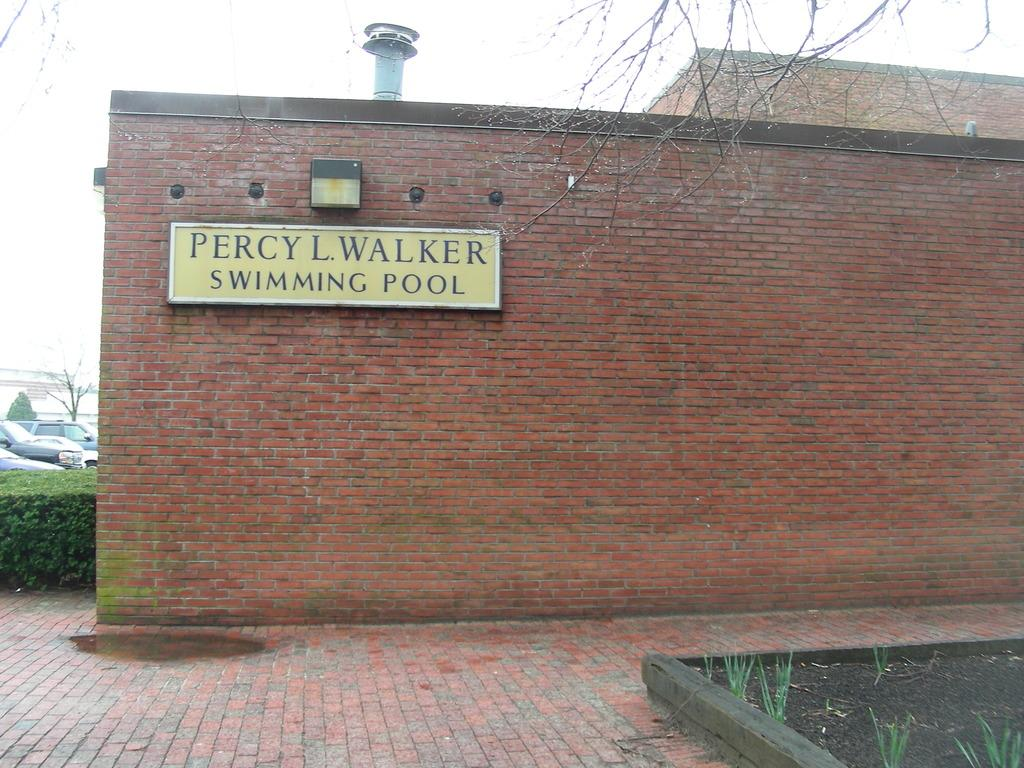What type of living organisms can be seen in the image? Plants and trees are visible in the image. What else can be seen in the image besides plants and trees? There are vehicles and a board attached to the wall of a house in the image. What is visible in the background of the image? The sky is visible in the background of the image. What type of salt can be seen on the breakfast table in the image? There is no breakfast table or salt present in the image. How many cows are grazing in the background of the image? There are no cows visible in the image; it features plants, trees, vehicles, and a board attached to a house. 